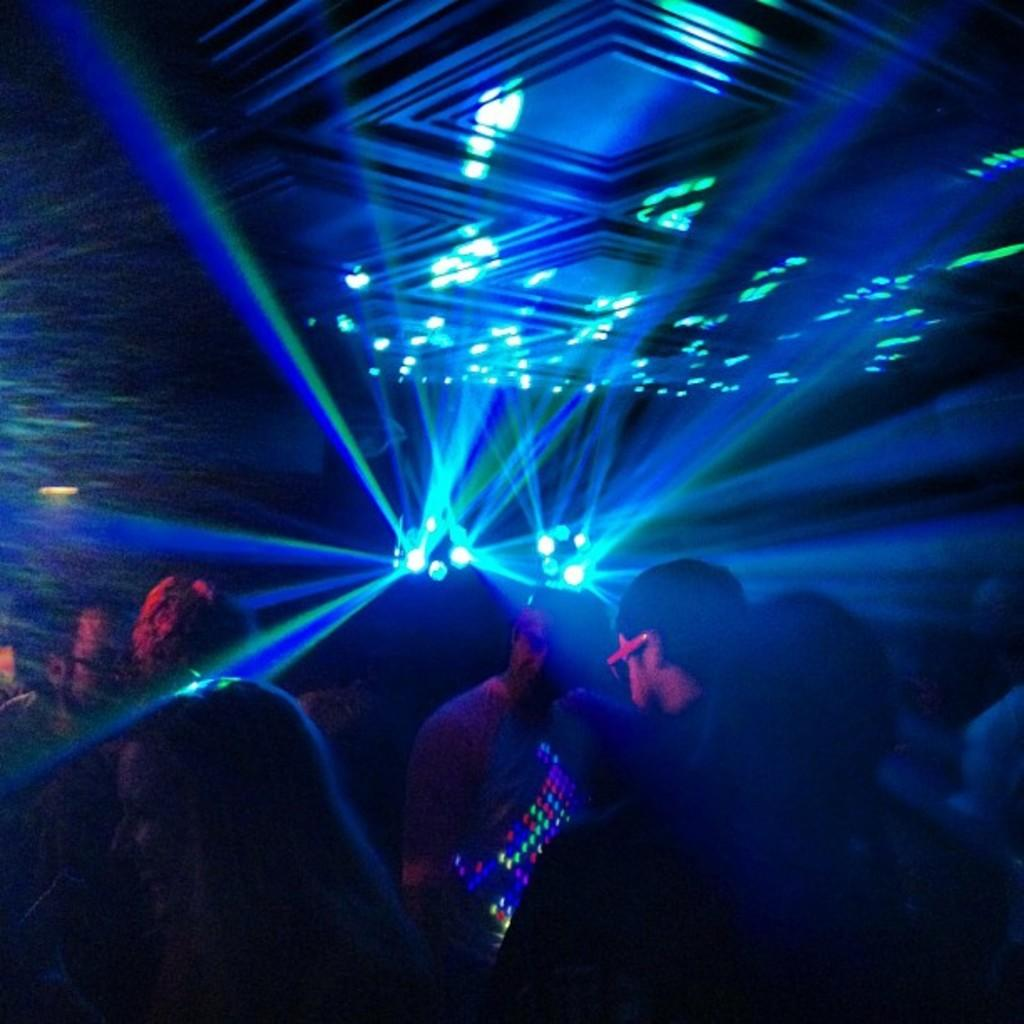Who or what is present in the image? There are people in the image. What color is predominant in the background lighting? The background lighting has blue color lights. How would you describe the overall brightness of the image? The image appears to be a bit dark. What type of garden can be seen in the image? There is no garden present in the image. What kind of bait is being used by the people in the image? There is no bait or fishing activity depicted in the image. 